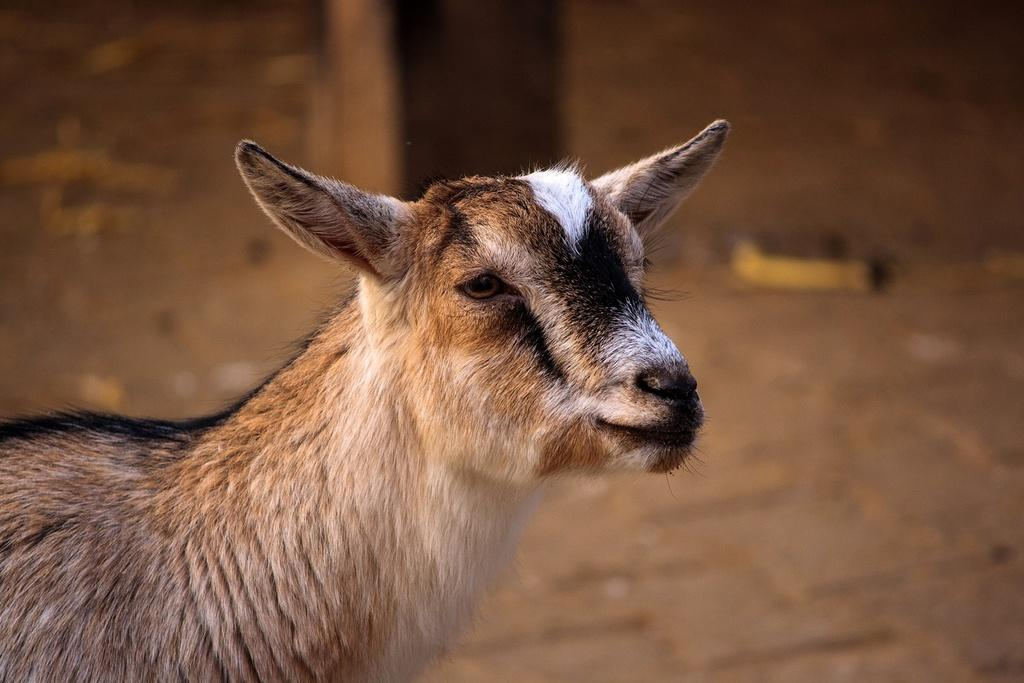What animal is present in the image? There is a goat in the image. What is the goat's position in the image? The goat is standing on the ground. What object can be seen in the image besides the goat? There is a wooden pole in the image. Can you describe the environment in the image? There may be dust visible in the image, which suggests a potentially dusty or dry environment. Who is the manager of the goat in the image? There is no indication in the image that the goat has a manager, as it is a wild animal. 